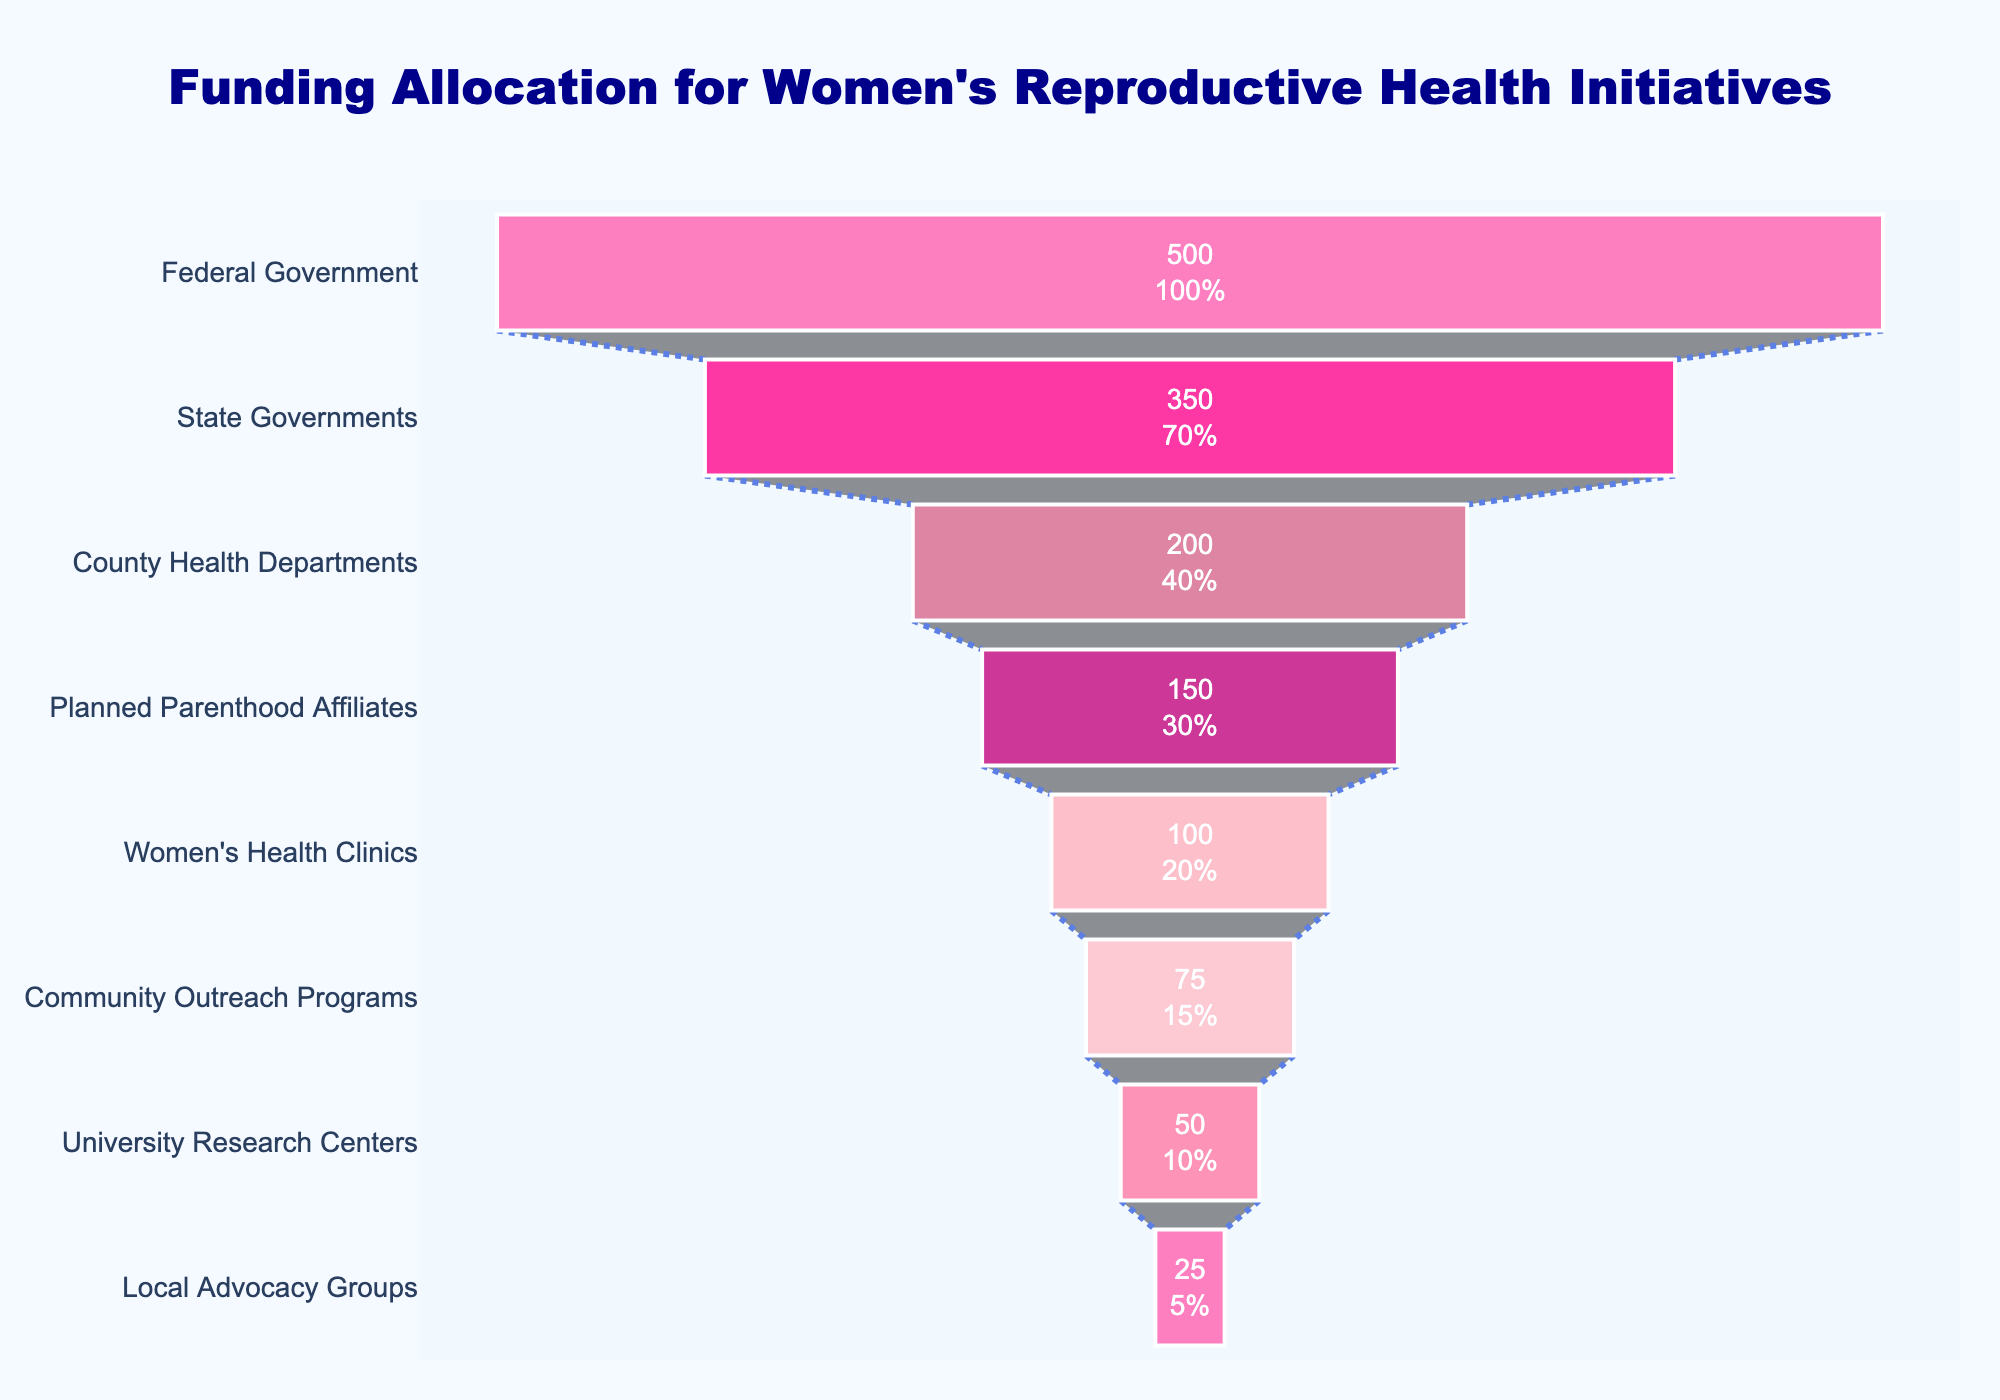What is the title of the funnel chart? The title is displayed at the top center of the chart. It indicates the chart's purpose which is to show the funding allocation for women's reproductive health initiatives.
Answer: Funding Allocation for Women's Reproductive Health Initiatives Which category received the highest amount of funding? The first section at the top of the funnel chart always represents the category with the highest funding amount, which is labeled as "Federal Government" with $500 million.
Answer: Federal Government How much funding did the State Governments receive? Locate the section labeled "State Governments" on the chart, it shows the specific funding amount allocated to this category.
Answer: $350 million What percentage of the initial federal funding amount goes to the Community Outreach Programs? First, find the funding amount for the Community Outreach Programs, which is $75 million. Divide this by the $500 million initial federal funding amount, and multiply by 100 to get the percentage.
Answer: 15% Which category received the least amount of funding? The last section at the bottom of the funnel represents the category with the least funding, labeled as "Local Advocacy Groups" with $25 million.
Answer: Local Advocacy Groups What is the total funding amount allocated from the federal down to the local community levels? Sum up all the funding amounts listed in the data: 500 + 350 + 200 + 150 + 100 + 75 + 50 + 25.
Answer: $1450 million How does the funding received by Planned Parenthood Affiliates compare to the Women's Health Clinics? Compare the two sections labeled "Planned Parenthood Affiliates" and "Women's Health Clinics." Planned Parenthood Affiliates received $150 million, which is $50 million more than the $100 million received by Women's Health Clinics.
Answer: $50 million more What percentage of the funding from the State Governments goes to University Research Centers? Find the funding amount for University Research Centers, which is $50 million. Divide this by the $350 million from State Governments, and multiply by 100 to get the percentage.
Answer: 14.3% What is the funding difference between County Health Departments and Community Outreach Programs? Identify the funding amounts for both categories: County Health Departments received $200 million, and Community Outreach Programs received $75 million. Subtract the latter from the former.
Answer: $125 million What color is used for the Women's Health Clinics section in the funnel chart? The segment labeled "Women's Health Clinics" is associated with a specific color in the chart, which appears pink.
Answer: Pink (light pink) 